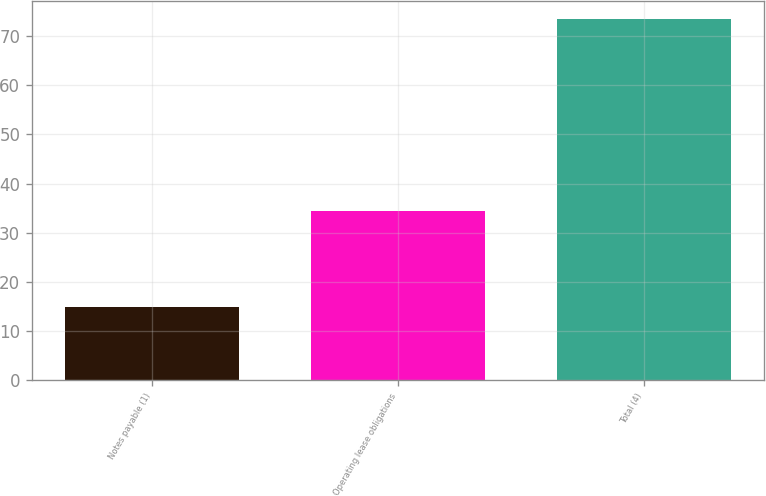Convert chart. <chart><loc_0><loc_0><loc_500><loc_500><bar_chart><fcel>Notes payable (1)<fcel>Operating lease obligations<fcel>Total (4)<nl><fcel>14.9<fcel>34.5<fcel>73.5<nl></chart> 